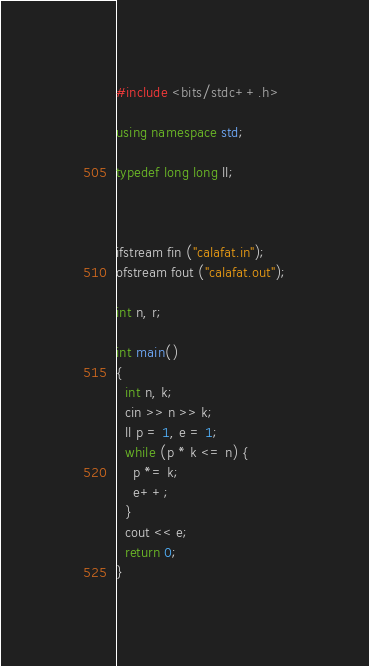Convert code to text. <code><loc_0><loc_0><loc_500><loc_500><_C++_>#include <bits/stdc++.h>

using namespace std;

typedef long long ll;



ifstream fin ("calafat.in");
ofstream fout ("calafat.out");

int n, r;

int main()
{
  int n, k;
  cin >> n >> k;
  ll p = 1, e = 1;
  while (p * k <= n) {
    p *= k;
    e++;
  }
  cout << e;
  return 0;
}
</code> 